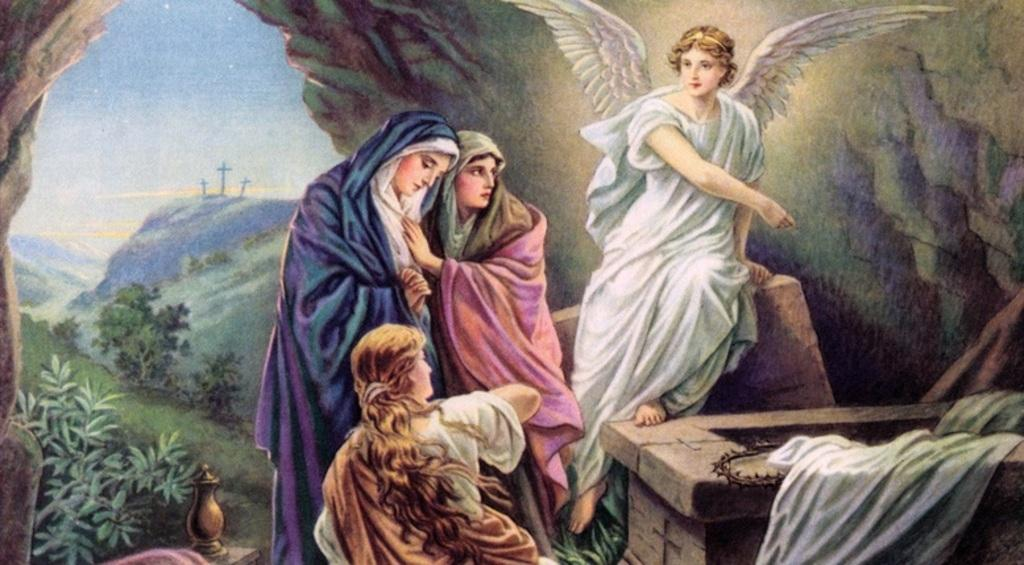What is featured on the poster in the image? The facts do not specify what is on the poster, so we cannot answer this question definitively. Who or what can be seen in the image? There are people in the image. What type of natural vegetation is present in the image? There are trees in the image. What type of structures can be seen in the image? There are poles in the image. What is the condition of the sky in the image? The sky is visible and appears cloudy in the image. What type of bone is being used as a club by one of the people in the image? There is no bone or club present in the image; the facts only mention people, a poster, trees, poles, and a cloudy sky. 